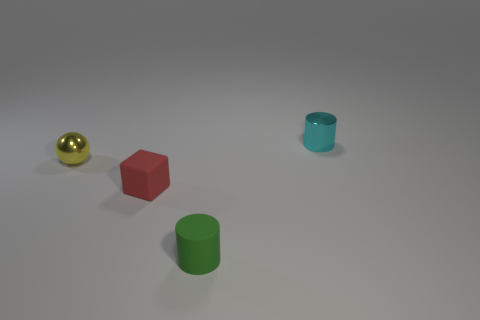Are there more cyan cylinders that are in front of the matte cube than cyan metallic cylinders on the left side of the tiny shiny ball?
Your answer should be compact. No. What shape is the metal object that is left of the cylinder behind the tiny shiny object that is in front of the cyan shiny thing?
Provide a short and direct response. Sphere. There is a metallic thing that is in front of the small cylinder behind the small green matte thing; what shape is it?
Make the answer very short. Sphere. Is there a red block made of the same material as the green object?
Provide a short and direct response. Yes. How many gray things are tiny matte cylinders or tiny metallic cylinders?
Provide a short and direct response. 0. Are there any other tiny balls of the same color as the small metal ball?
Provide a short and direct response. No. There is a thing that is the same material as the cube; what is its size?
Offer a terse response. Small. What number of cylinders are either tiny purple metal things or green matte objects?
Provide a short and direct response. 1. Are there more tiny cubes than tiny green metallic balls?
Ensure brevity in your answer.  Yes. How many yellow shiny objects have the same size as the red thing?
Your answer should be very brief. 1. 